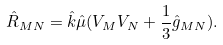Convert formula to latex. <formula><loc_0><loc_0><loc_500><loc_500>\hat { R } _ { M N } = \hat { k } \hat { \mu } ( V _ { M } V _ { N } + \frac { 1 } { 3 } \hat { g } _ { M N } ) .</formula> 